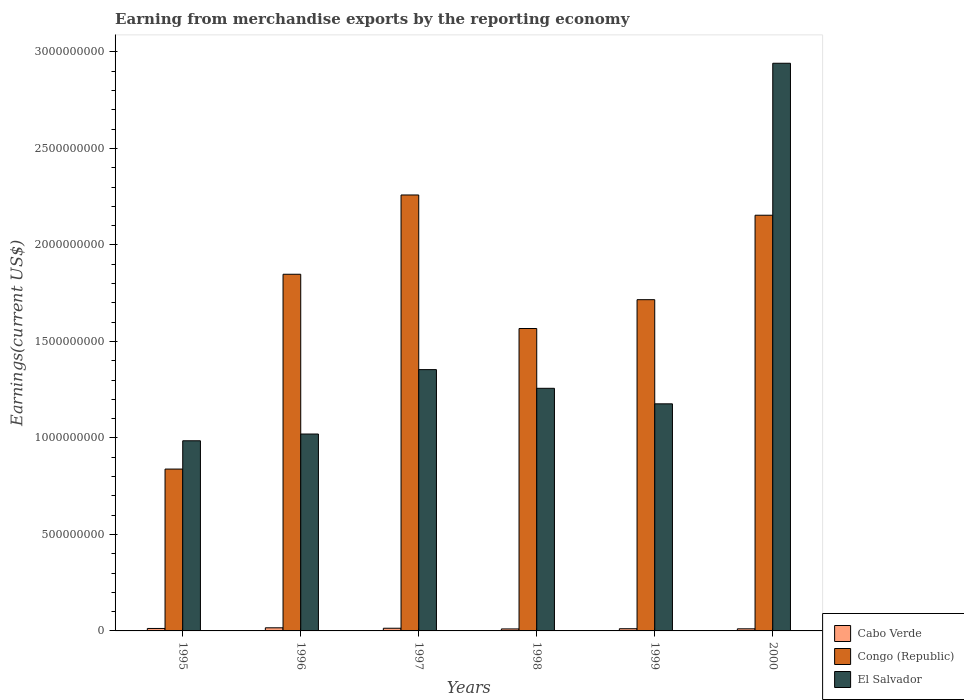Are the number of bars on each tick of the X-axis equal?
Provide a succinct answer. Yes. What is the label of the 6th group of bars from the left?
Keep it short and to the point. 2000. What is the amount earned from merchandise exports in El Salvador in 1998?
Provide a succinct answer. 1.26e+09. Across all years, what is the maximum amount earned from merchandise exports in El Salvador?
Keep it short and to the point. 2.94e+09. Across all years, what is the minimum amount earned from merchandise exports in Congo (Republic)?
Offer a very short reply. 8.39e+08. What is the total amount earned from merchandise exports in El Salvador in the graph?
Offer a terse response. 8.73e+09. What is the difference between the amount earned from merchandise exports in El Salvador in 1996 and that in 1998?
Your answer should be compact. -2.37e+08. What is the difference between the amount earned from merchandise exports in El Salvador in 1996 and the amount earned from merchandise exports in Cabo Verde in 1995?
Offer a terse response. 1.01e+09. What is the average amount earned from merchandise exports in Cabo Verde per year?
Ensure brevity in your answer.  1.26e+07. In the year 1999, what is the difference between the amount earned from merchandise exports in Congo (Republic) and amount earned from merchandise exports in El Salvador?
Ensure brevity in your answer.  5.40e+08. In how many years, is the amount earned from merchandise exports in Cabo Verde greater than 2100000000 US$?
Your answer should be very brief. 0. What is the ratio of the amount earned from merchandise exports in Congo (Republic) in 1998 to that in 2000?
Ensure brevity in your answer.  0.73. Is the amount earned from merchandise exports in Congo (Republic) in 1996 less than that in 2000?
Make the answer very short. Yes. Is the difference between the amount earned from merchandise exports in Congo (Republic) in 1997 and 1998 greater than the difference between the amount earned from merchandise exports in El Salvador in 1997 and 1998?
Make the answer very short. Yes. What is the difference between the highest and the second highest amount earned from merchandise exports in Cabo Verde?
Offer a very short reply. 2.28e+06. What is the difference between the highest and the lowest amount earned from merchandise exports in El Salvador?
Your answer should be very brief. 1.96e+09. Is the sum of the amount earned from merchandise exports in El Salvador in 1996 and 2000 greater than the maximum amount earned from merchandise exports in Congo (Republic) across all years?
Your response must be concise. Yes. What does the 1st bar from the left in 1998 represents?
Your answer should be compact. Cabo Verde. What does the 1st bar from the right in 1999 represents?
Your answer should be very brief. El Salvador. Does the graph contain grids?
Keep it short and to the point. No. Where does the legend appear in the graph?
Keep it short and to the point. Bottom right. What is the title of the graph?
Give a very brief answer. Earning from merchandise exports by the reporting economy. Does "Central African Republic" appear as one of the legend labels in the graph?
Ensure brevity in your answer.  No. What is the label or title of the X-axis?
Make the answer very short. Years. What is the label or title of the Y-axis?
Offer a very short reply. Earnings(current US$). What is the Earnings(current US$) in Cabo Verde in 1995?
Your answer should be compact. 1.27e+07. What is the Earnings(current US$) in Congo (Republic) in 1995?
Your response must be concise. 8.39e+08. What is the Earnings(current US$) in El Salvador in 1995?
Your answer should be very brief. 9.85e+08. What is the Earnings(current US$) in Cabo Verde in 1996?
Your answer should be compact. 1.62e+07. What is the Earnings(current US$) in Congo (Republic) in 1996?
Give a very brief answer. 1.85e+09. What is the Earnings(current US$) in El Salvador in 1996?
Your answer should be very brief. 1.02e+09. What is the Earnings(current US$) of Cabo Verde in 1997?
Provide a succinct answer. 1.39e+07. What is the Earnings(current US$) of Congo (Republic) in 1997?
Provide a succinct answer. 2.26e+09. What is the Earnings(current US$) in El Salvador in 1997?
Ensure brevity in your answer.  1.35e+09. What is the Earnings(current US$) in Cabo Verde in 1998?
Offer a terse response. 1.04e+07. What is the Earnings(current US$) in Congo (Republic) in 1998?
Your answer should be very brief. 1.57e+09. What is the Earnings(current US$) of El Salvador in 1998?
Give a very brief answer. 1.26e+09. What is the Earnings(current US$) of Cabo Verde in 1999?
Your answer should be very brief. 1.14e+07. What is the Earnings(current US$) in Congo (Republic) in 1999?
Give a very brief answer. 1.72e+09. What is the Earnings(current US$) of El Salvador in 1999?
Your response must be concise. 1.18e+09. What is the Earnings(current US$) in Cabo Verde in 2000?
Make the answer very short. 1.09e+07. What is the Earnings(current US$) in Congo (Republic) in 2000?
Provide a succinct answer. 2.15e+09. What is the Earnings(current US$) in El Salvador in 2000?
Give a very brief answer. 2.94e+09. Across all years, what is the maximum Earnings(current US$) of Cabo Verde?
Offer a terse response. 1.62e+07. Across all years, what is the maximum Earnings(current US$) of Congo (Republic)?
Keep it short and to the point. 2.26e+09. Across all years, what is the maximum Earnings(current US$) of El Salvador?
Your answer should be very brief. 2.94e+09. Across all years, what is the minimum Earnings(current US$) in Cabo Verde?
Keep it short and to the point. 1.04e+07. Across all years, what is the minimum Earnings(current US$) in Congo (Republic)?
Your answer should be compact. 8.39e+08. Across all years, what is the minimum Earnings(current US$) in El Salvador?
Provide a short and direct response. 9.85e+08. What is the total Earnings(current US$) of Cabo Verde in the graph?
Your answer should be compact. 7.55e+07. What is the total Earnings(current US$) of Congo (Republic) in the graph?
Provide a succinct answer. 1.04e+1. What is the total Earnings(current US$) in El Salvador in the graph?
Provide a short and direct response. 8.73e+09. What is the difference between the Earnings(current US$) of Cabo Verde in 1995 and that in 1996?
Ensure brevity in your answer.  -3.45e+06. What is the difference between the Earnings(current US$) in Congo (Republic) in 1995 and that in 1996?
Keep it short and to the point. -1.01e+09. What is the difference between the Earnings(current US$) of El Salvador in 1995 and that in 1996?
Give a very brief answer. -3.50e+07. What is the difference between the Earnings(current US$) of Cabo Verde in 1995 and that in 1997?
Ensure brevity in your answer.  -1.16e+06. What is the difference between the Earnings(current US$) in Congo (Republic) in 1995 and that in 1997?
Ensure brevity in your answer.  -1.42e+09. What is the difference between the Earnings(current US$) in El Salvador in 1995 and that in 1997?
Give a very brief answer. -3.69e+08. What is the difference between the Earnings(current US$) in Cabo Verde in 1995 and that in 1998?
Ensure brevity in your answer.  2.39e+06. What is the difference between the Earnings(current US$) of Congo (Republic) in 1995 and that in 1998?
Your answer should be very brief. -7.28e+08. What is the difference between the Earnings(current US$) of El Salvador in 1995 and that in 1998?
Make the answer very short. -2.72e+08. What is the difference between the Earnings(current US$) in Cabo Verde in 1995 and that in 1999?
Give a very brief answer. 1.35e+06. What is the difference between the Earnings(current US$) of Congo (Republic) in 1995 and that in 1999?
Your answer should be very brief. -8.78e+08. What is the difference between the Earnings(current US$) of El Salvador in 1995 and that in 1999?
Your answer should be compact. -1.91e+08. What is the difference between the Earnings(current US$) in Cabo Verde in 1995 and that in 2000?
Your answer should be compact. 1.85e+06. What is the difference between the Earnings(current US$) in Congo (Republic) in 1995 and that in 2000?
Give a very brief answer. -1.32e+09. What is the difference between the Earnings(current US$) in El Salvador in 1995 and that in 2000?
Offer a very short reply. -1.96e+09. What is the difference between the Earnings(current US$) of Cabo Verde in 1996 and that in 1997?
Provide a short and direct response. 2.28e+06. What is the difference between the Earnings(current US$) in Congo (Republic) in 1996 and that in 1997?
Your answer should be compact. -4.11e+08. What is the difference between the Earnings(current US$) of El Salvador in 1996 and that in 1997?
Keep it short and to the point. -3.34e+08. What is the difference between the Earnings(current US$) in Cabo Verde in 1996 and that in 1998?
Provide a short and direct response. 5.83e+06. What is the difference between the Earnings(current US$) in Congo (Republic) in 1996 and that in 1998?
Your answer should be compact. 2.81e+08. What is the difference between the Earnings(current US$) in El Salvador in 1996 and that in 1998?
Your response must be concise. -2.37e+08. What is the difference between the Earnings(current US$) in Cabo Verde in 1996 and that in 1999?
Your answer should be very brief. 4.79e+06. What is the difference between the Earnings(current US$) of Congo (Republic) in 1996 and that in 1999?
Ensure brevity in your answer.  1.32e+08. What is the difference between the Earnings(current US$) in El Salvador in 1996 and that in 1999?
Ensure brevity in your answer.  -1.56e+08. What is the difference between the Earnings(current US$) in Cabo Verde in 1996 and that in 2000?
Make the answer very short. 5.30e+06. What is the difference between the Earnings(current US$) in Congo (Republic) in 1996 and that in 2000?
Ensure brevity in your answer.  -3.06e+08. What is the difference between the Earnings(current US$) in El Salvador in 1996 and that in 2000?
Offer a terse response. -1.92e+09. What is the difference between the Earnings(current US$) of Cabo Verde in 1997 and that in 1998?
Provide a succinct answer. 3.55e+06. What is the difference between the Earnings(current US$) of Congo (Republic) in 1997 and that in 1998?
Offer a terse response. 6.92e+08. What is the difference between the Earnings(current US$) of El Salvador in 1997 and that in 1998?
Your answer should be compact. 9.68e+07. What is the difference between the Earnings(current US$) of Cabo Verde in 1997 and that in 1999?
Offer a terse response. 2.51e+06. What is the difference between the Earnings(current US$) in Congo (Republic) in 1997 and that in 1999?
Make the answer very short. 5.42e+08. What is the difference between the Earnings(current US$) in El Salvador in 1997 and that in 1999?
Give a very brief answer. 1.77e+08. What is the difference between the Earnings(current US$) in Cabo Verde in 1997 and that in 2000?
Your response must be concise. 3.02e+06. What is the difference between the Earnings(current US$) of Congo (Republic) in 1997 and that in 2000?
Ensure brevity in your answer.  1.05e+08. What is the difference between the Earnings(current US$) of El Salvador in 1997 and that in 2000?
Give a very brief answer. -1.59e+09. What is the difference between the Earnings(current US$) of Cabo Verde in 1998 and that in 1999?
Give a very brief answer. -1.04e+06. What is the difference between the Earnings(current US$) of Congo (Republic) in 1998 and that in 1999?
Give a very brief answer. -1.49e+08. What is the difference between the Earnings(current US$) of El Salvador in 1998 and that in 1999?
Your answer should be compact. 8.04e+07. What is the difference between the Earnings(current US$) in Cabo Verde in 1998 and that in 2000?
Provide a succinct answer. -5.31e+05. What is the difference between the Earnings(current US$) in Congo (Republic) in 1998 and that in 2000?
Offer a very short reply. -5.87e+08. What is the difference between the Earnings(current US$) in El Salvador in 1998 and that in 2000?
Your answer should be very brief. -1.68e+09. What is the difference between the Earnings(current US$) of Cabo Verde in 1999 and that in 2000?
Ensure brevity in your answer.  5.10e+05. What is the difference between the Earnings(current US$) in Congo (Republic) in 1999 and that in 2000?
Keep it short and to the point. -4.38e+08. What is the difference between the Earnings(current US$) in El Salvador in 1999 and that in 2000?
Offer a terse response. -1.76e+09. What is the difference between the Earnings(current US$) of Cabo Verde in 1995 and the Earnings(current US$) of Congo (Republic) in 1996?
Give a very brief answer. -1.84e+09. What is the difference between the Earnings(current US$) in Cabo Verde in 1995 and the Earnings(current US$) in El Salvador in 1996?
Your answer should be compact. -1.01e+09. What is the difference between the Earnings(current US$) in Congo (Republic) in 1995 and the Earnings(current US$) in El Salvador in 1996?
Give a very brief answer. -1.82e+08. What is the difference between the Earnings(current US$) in Cabo Verde in 1995 and the Earnings(current US$) in Congo (Republic) in 1997?
Keep it short and to the point. -2.25e+09. What is the difference between the Earnings(current US$) of Cabo Verde in 1995 and the Earnings(current US$) of El Salvador in 1997?
Offer a very short reply. -1.34e+09. What is the difference between the Earnings(current US$) of Congo (Republic) in 1995 and the Earnings(current US$) of El Salvador in 1997?
Your response must be concise. -5.15e+08. What is the difference between the Earnings(current US$) of Cabo Verde in 1995 and the Earnings(current US$) of Congo (Republic) in 1998?
Provide a succinct answer. -1.55e+09. What is the difference between the Earnings(current US$) in Cabo Verde in 1995 and the Earnings(current US$) in El Salvador in 1998?
Your answer should be very brief. -1.24e+09. What is the difference between the Earnings(current US$) in Congo (Republic) in 1995 and the Earnings(current US$) in El Salvador in 1998?
Give a very brief answer. -4.18e+08. What is the difference between the Earnings(current US$) in Cabo Verde in 1995 and the Earnings(current US$) in Congo (Republic) in 1999?
Provide a succinct answer. -1.70e+09. What is the difference between the Earnings(current US$) in Cabo Verde in 1995 and the Earnings(current US$) in El Salvador in 1999?
Offer a terse response. -1.16e+09. What is the difference between the Earnings(current US$) of Congo (Republic) in 1995 and the Earnings(current US$) of El Salvador in 1999?
Your answer should be very brief. -3.38e+08. What is the difference between the Earnings(current US$) of Cabo Verde in 1995 and the Earnings(current US$) of Congo (Republic) in 2000?
Provide a short and direct response. -2.14e+09. What is the difference between the Earnings(current US$) in Cabo Verde in 1995 and the Earnings(current US$) in El Salvador in 2000?
Your answer should be very brief. -2.93e+09. What is the difference between the Earnings(current US$) in Congo (Republic) in 1995 and the Earnings(current US$) in El Salvador in 2000?
Keep it short and to the point. -2.10e+09. What is the difference between the Earnings(current US$) in Cabo Verde in 1996 and the Earnings(current US$) in Congo (Republic) in 1997?
Your response must be concise. -2.24e+09. What is the difference between the Earnings(current US$) of Cabo Verde in 1996 and the Earnings(current US$) of El Salvador in 1997?
Your answer should be very brief. -1.34e+09. What is the difference between the Earnings(current US$) in Congo (Republic) in 1996 and the Earnings(current US$) in El Salvador in 1997?
Your answer should be compact. 4.94e+08. What is the difference between the Earnings(current US$) of Cabo Verde in 1996 and the Earnings(current US$) of Congo (Republic) in 1998?
Offer a very short reply. -1.55e+09. What is the difference between the Earnings(current US$) in Cabo Verde in 1996 and the Earnings(current US$) in El Salvador in 1998?
Offer a very short reply. -1.24e+09. What is the difference between the Earnings(current US$) in Congo (Republic) in 1996 and the Earnings(current US$) in El Salvador in 1998?
Give a very brief answer. 5.91e+08. What is the difference between the Earnings(current US$) in Cabo Verde in 1996 and the Earnings(current US$) in Congo (Republic) in 1999?
Your answer should be very brief. -1.70e+09. What is the difference between the Earnings(current US$) in Cabo Verde in 1996 and the Earnings(current US$) in El Salvador in 1999?
Provide a short and direct response. -1.16e+09. What is the difference between the Earnings(current US$) in Congo (Republic) in 1996 and the Earnings(current US$) in El Salvador in 1999?
Provide a short and direct response. 6.71e+08. What is the difference between the Earnings(current US$) in Cabo Verde in 1996 and the Earnings(current US$) in Congo (Republic) in 2000?
Keep it short and to the point. -2.14e+09. What is the difference between the Earnings(current US$) of Cabo Verde in 1996 and the Earnings(current US$) of El Salvador in 2000?
Keep it short and to the point. -2.93e+09. What is the difference between the Earnings(current US$) of Congo (Republic) in 1996 and the Earnings(current US$) of El Salvador in 2000?
Your answer should be very brief. -1.09e+09. What is the difference between the Earnings(current US$) of Cabo Verde in 1997 and the Earnings(current US$) of Congo (Republic) in 1998?
Your response must be concise. -1.55e+09. What is the difference between the Earnings(current US$) of Cabo Verde in 1997 and the Earnings(current US$) of El Salvador in 1998?
Keep it short and to the point. -1.24e+09. What is the difference between the Earnings(current US$) of Congo (Republic) in 1997 and the Earnings(current US$) of El Salvador in 1998?
Provide a short and direct response. 1.00e+09. What is the difference between the Earnings(current US$) in Cabo Verde in 1997 and the Earnings(current US$) in Congo (Republic) in 1999?
Your answer should be very brief. -1.70e+09. What is the difference between the Earnings(current US$) of Cabo Verde in 1997 and the Earnings(current US$) of El Salvador in 1999?
Give a very brief answer. -1.16e+09. What is the difference between the Earnings(current US$) of Congo (Republic) in 1997 and the Earnings(current US$) of El Salvador in 1999?
Provide a short and direct response. 1.08e+09. What is the difference between the Earnings(current US$) of Cabo Verde in 1997 and the Earnings(current US$) of Congo (Republic) in 2000?
Give a very brief answer. -2.14e+09. What is the difference between the Earnings(current US$) of Cabo Verde in 1997 and the Earnings(current US$) of El Salvador in 2000?
Offer a very short reply. -2.93e+09. What is the difference between the Earnings(current US$) in Congo (Republic) in 1997 and the Earnings(current US$) in El Salvador in 2000?
Your answer should be compact. -6.83e+08. What is the difference between the Earnings(current US$) of Cabo Verde in 1998 and the Earnings(current US$) of Congo (Republic) in 1999?
Make the answer very short. -1.71e+09. What is the difference between the Earnings(current US$) in Cabo Verde in 1998 and the Earnings(current US$) in El Salvador in 1999?
Ensure brevity in your answer.  -1.17e+09. What is the difference between the Earnings(current US$) in Congo (Republic) in 1998 and the Earnings(current US$) in El Salvador in 1999?
Provide a short and direct response. 3.90e+08. What is the difference between the Earnings(current US$) of Cabo Verde in 1998 and the Earnings(current US$) of Congo (Republic) in 2000?
Offer a terse response. -2.14e+09. What is the difference between the Earnings(current US$) in Cabo Verde in 1998 and the Earnings(current US$) in El Salvador in 2000?
Your response must be concise. -2.93e+09. What is the difference between the Earnings(current US$) of Congo (Republic) in 1998 and the Earnings(current US$) of El Salvador in 2000?
Your answer should be compact. -1.37e+09. What is the difference between the Earnings(current US$) of Cabo Verde in 1999 and the Earnings(current US$) of Congo (Republic) in 2000?
Your response must be concise. -2.14e+09. What is the difference between the Earnings(current US$) of Cabo Verde in 1999 and the Earnings(current US$) of El Salvador in 2000?
Your answer should be compact. -2.93e+09. What is the difference between the Earnings(current US$) in Congo (Republic) in 1999 and the Earnings(current US$) in El Salvador in 2000?
Ensure brevity in your answer.  -1.23e+09. What is the average Earnings(current US$) in Cabo Verde per year?
Give a very brief answer. 1.26e+07. What is the average Earnings(current US$) of Congo (Republic) per year?
Ensure brevity in your answer.  1.73e+09. What is the average Earnings(current US$) of El Salvador per year?
Offer a terse response. 1.46e+09. In the year 1995, what is the difference between the Earnings(current US$) in Cabo Verde and Earnings(current US$) in Congo (Republic)?
Ensure brevity in your answer.  -8.26e+08. In the year 1995, what is the difference between the Earnings(current US$) in Cabo Verde and Earnings(current US$) in El Salvador?
Your answer should be compact. -9.72e+08. In the year 1995, what is the difference between the Earnings(current US$) in Congo (Republic) and Earnings(current US$) in El Salvador?
Ensure brevity in your answer.  -1.47e+08. In the year 1996, what is the difference between the Earnings(current US$) of Cabo Verde and Earnings(current US$) of Congo (Republic)?
Offer a terse response. -1.83e+09. In the year 1996, what is the difference between the Earnings(current US$) in Cabo Verde and Earnings(current US$) in El Salvador?
Provide a succinct answer. -1.00e+09. In the year 1996, what is the difference between the Earnings(current US$) in Congo (Republic) and Earnings(current US$) in El Salvador?
Make the answer very short. 8.28e+08. In the year 1997, what is the difference between the Earnings(current US$) in Cabo Verde and Earnings(current US$) in Congo (Republic)?
Keep it short and to the point. -2.24e+09. In the year 1997, what is the difference between the Earnings(current US$) of Cabo Verde and Earnings(current US$) of El Salvador?
Make the answer very short. -1.34e+09. In the year 1997, what is the difference between the Earnings(current US$) in Congo (Republic) and Earnings(current US$) in El Salvador?
Offer a very short reply. 9.05e+08. In the year 1998, what is the difference between the Earnings(current US$) in Cabo Verde and Earnings(current US$) in Congo (Republic)?
Offer a very short reply. -1.56e+09. In the year 1998, what is the difference between the Earnings(current US$) in Cabo Verde and Earnings(current US$) in El Salvador?
Provide a short and direct response. -1.25e+09. In the year 1998, what is the difference between the Earnings(current US$) in Congo (Republic) and Earnings(current US$) in El Salvador?
Your answer should be compact. 3.10e+08. In the year 1999, what is the difference between the Earnings(current US$) of Cabo Verde and Earnings(current US$) of Congo (Republic)?
Provide a short and direct response. -1.70e+09. In the year 1999, what is the difference between the Earnings(current US$) of Cabo Verde and Earnings(current US$) of El Salvador?
Your answer should be very brief. -1.17e+09. In the year 1999, what is the difference between the Earnings(current US$) of Congo (Republic) and Earnings(current US$) of El Salvador?
Make the answer very short. 5.40e+08. In the year 2000, what is the difference between the Earnings(current US$) in Cabo Verde and Earnings(current US$) in Congo (Republic)?
Offer a terse response. -2.14e+09. In the year 2000, what is the difference between the Earnings(current US$) in Cabo Verde and Earnings(current US$) in El Salvador?
Your answer should be compact. -2.93e+09. In the year 2000, what is the difference between the Earnings(current US$) in Congo (Republic) and Earnings(current US$) in El Salvador?
Ensure brevity in your answer.  -7.87e+08. What is the ratio of the Earnings(current US$) of Cabo Verde in 1995 to that in 1996?
Your answer should be very brief. 0.79. What is the ratio of the Earnings(current US$) in Congo (Republic) in 1995 to that in 1996?
Ensure brevity in your answer.  0.45. What is the ratio of the Earnings(current US$) in El Salvador in 1995 to that in 1996?
Offer a terse response. 0.97. What is the ratio of the Earnings(current US$) of Cabo Verde in 1995 to that in 1997?
Your answer should be very brief. 0.92. What is the ratio of the Earnings(current US$) in Congo (Republic) in 1995 to that in 1997?
Your response must be concise. 0.37. What is the ratio of the Earnings(current US$) in El Salvador in 1995 to that in 1997?
Your answer should be compact. 0.73. What is the ratio of the Earnings(current US$) in Cabo Verde in 1995 to that in 1998?
Your answer should be very brief. 1.23. What is the ratio of the Earnings(current US$) in Congo (Republic) in 1995 to that in 1998?
Make the answer very short. 0.54. What is the ratio of the Earnings(current US$) in El Salvador in 1995 to that in 1998?
Your answer should be very brief. 0.78. What is the ratio of the Earnings(current US$) of Cabo Verde in 1995 to that in 1999?
Your answer should be very brief. 1.12. What is the ratio of the Earnings(current US$) of Congo (Republic) in 1995 to that in 1999?
Your response must be concise. 0.49. What is the ratio of the Earnings(current US$) of El Salvador in 1995 to that in 1999?
Keep it short and to the point. 0.84. What is the ratio of the Earnings(current US$) of Cabo Verde in 1995 to that in 2000?
Offer a terse response. 1.17. What is the ratio of the Earnings(current US$) in Congo (Republic) in 1995 to that in 2000?
Your answer should be compact. 0.39. What is the ratio of the Earnings(current US$) in El Salvador in 1995 to that in 2000?
Your answer should be compact. 0.34. What is the ratio of the Earnings(current US$) of Cabo Verde in 1996 to that in 1997?
Ensure brevity in your answer.  1.16. What is the ratio of the Earnings(current US$) of Congo (Republic) in 1996 to that in 1997?
Keep it short and to the point. 0.82. What is the ratio of the Earnings(current US$) in El Salvador in 1996 to that in 1997?
Ensure brevity in your answer.  0.75. What is the ratio of the Earnings(current US$) of Cabo Verde in 1996 to that in 1998?
Make the answer very short. 1.56. What is the ratio of the Earnings(current US$) in Congo (Republic) in 1996 to that in 1998?
Keep it short and to the point. 1.18. What is the ratio of the Earnings(current US$) in El Salvador in 1996 to that in 1998?
Your answer should be compact. 0.81. What is the ratio of the Earnings(current US$) in Cabo Verde in 1996 to that in 1999?
Ensure brevity in your answer.  1.42. What is the ratio of the Earnings(current US$) of Congo (Republic) in 1996 to that in 1999?
Give a very brief answer. 1.08. What is the ratio of the Earnings(current US$) of El Salvador in 1996 to that in 1999?
Offer a very short reply. 0.87. What is the ratio of the Earnings(current US$) of Cabo Verde in 1996 to that in 2000?
Your answer should be very brief. 1.49. What is the ratio of the Earnings(current US$) of Congo (Republic) in 1996 to that in 2000?
Make the answer very short. 0.86. What is the ratio of the Earnings(current US$) in El Salvador in 1996 to that in 2000?
Make the answer very short. 0.35. What is the ratio of the Earnings(current US$) of Cabo Verde in 1997 to that in 1998?
Give a very brief answer. 1.34. What is the ratio of the Earnings(current US$) of Congo (Republic) in 1997 to that in 1998?
Provide a succinct answer. 1.44. What is the ratio of the Earnings(current US$) of El Salvador in 1997 to that in 1998?
Provide a short and direct response. 1.08. What is the ratio of the Earnings(current US$) in Cabo Verde in 1997 to that in 1999?
Give a very brief answer. 1.22. What is the ratio of the Earnings(current US$) of Congo (Republic) in 1997 to that in 1999?
Your answer should be very brief. 1.32. What is the ratio of the Earnings(current US$) of El Salvador in 1997 to that in 1999?
Make the answer very short. 1.15. What is the ratio of the Earnings(current US$) of Cabo Verde in 1997 to that in 2000?
Your answer should be very brief. 1.28. What is the ratio of the Earnings(current US$) of Congo (Republic) in 1997 to that in 2000?
Your answer should be very brief. 1.05. What is the ratio of the Earnings(current US$) of El Salvador in 1997 to that in 2000?
Offer a terse response. 0.46. What is the ratio of the Earnings(current US$) of Cabo Verde in 1998 to that in 1999?
Your answer should be compact. 0.91. What is the ratio of the Earnings(current US$) in El Salvador in 1998 to that in 1999?
Ensure brevity in your answer.  1.07. What is the ratio of the Earnings(current US$) of Cabo Verde in 1998 to that in 2000?
Offer a very short reply. 0.95. What is the ratio of the Earnings(current US$) in Congo (Republic) in 1998 to that in 2000?
Keep it short and to the point. 0.73. What is the ratio of the Earnings(current US$) of El Salvador in 1998 to that in 2000?
Make the answer very short. 0.43. What is the ratio of the Earnings(current US$) of Cabo Verde in 1999 to that in 2000?
Ensure brevity in your answer.  1.05. What is the ratio of the Earnings(current US$) of Congo (Republic) in 1999 to that in 2000?
Provide a short and direct response. 0.8. What is the ratio of the Earnings(current US$) of El Salvador in 1999 to that in 2000?
Keep it short and to the point. 0.4. What is the difference between the highest and the second highest Earnings(current US$) of Cabo Verde?
Offer a terse response. 2.28e+06. What is the difference between the highest and the second highest Earnings(current US$) in Congo (Republic)?
Your answer should be very brief. 1.05e+08. What is the difference between the highest and the second highest Earnings(current US$) in El Salvador?
Offer a terse response. 1.59e+09. What is the difference between the highest and the lowest Earnings(current US$) of Cabo Verde?
Provide a succinct answer. 5.83e+06. What is the difference between the highest and the lowest Earnings(current US$) in Congo (Republic)?
Provide a short and direct response. 1.42e+09. What is the difference between the highest and the lowest Earnings(current US$) of El Salvador?
Make the answer very short. 1.96e+09. 